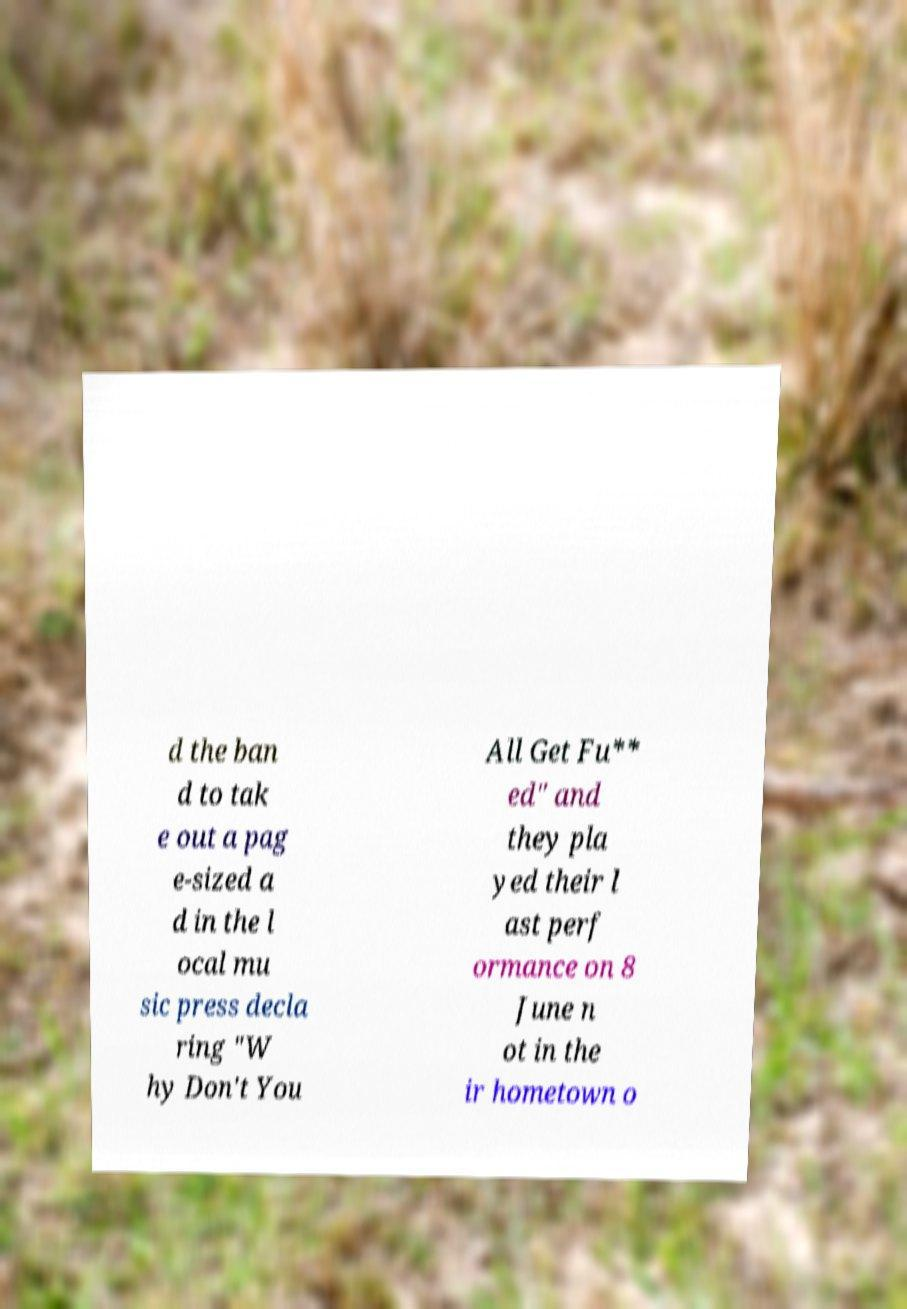Can you accurately transcribe the text from the provided image for me? d the ban d to tak e out a pag e-sized a d in the l ocal mu sic press decla ring "W hy Don't You All Get Fu** ed" and they pla yed their l ast perf ormance on 8 June n ot in the ir hometown o 